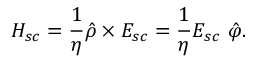Convert formula to latex. <formula><loc_0><loc_0><loc_500><loc_500>H _ { s c } = \frac { 1 } { \eta } \hat { \rho } \times E _ { s c } = \frac { 1 } { \eta } E _ { s c } \ \hat { \varphi } .</formula> 